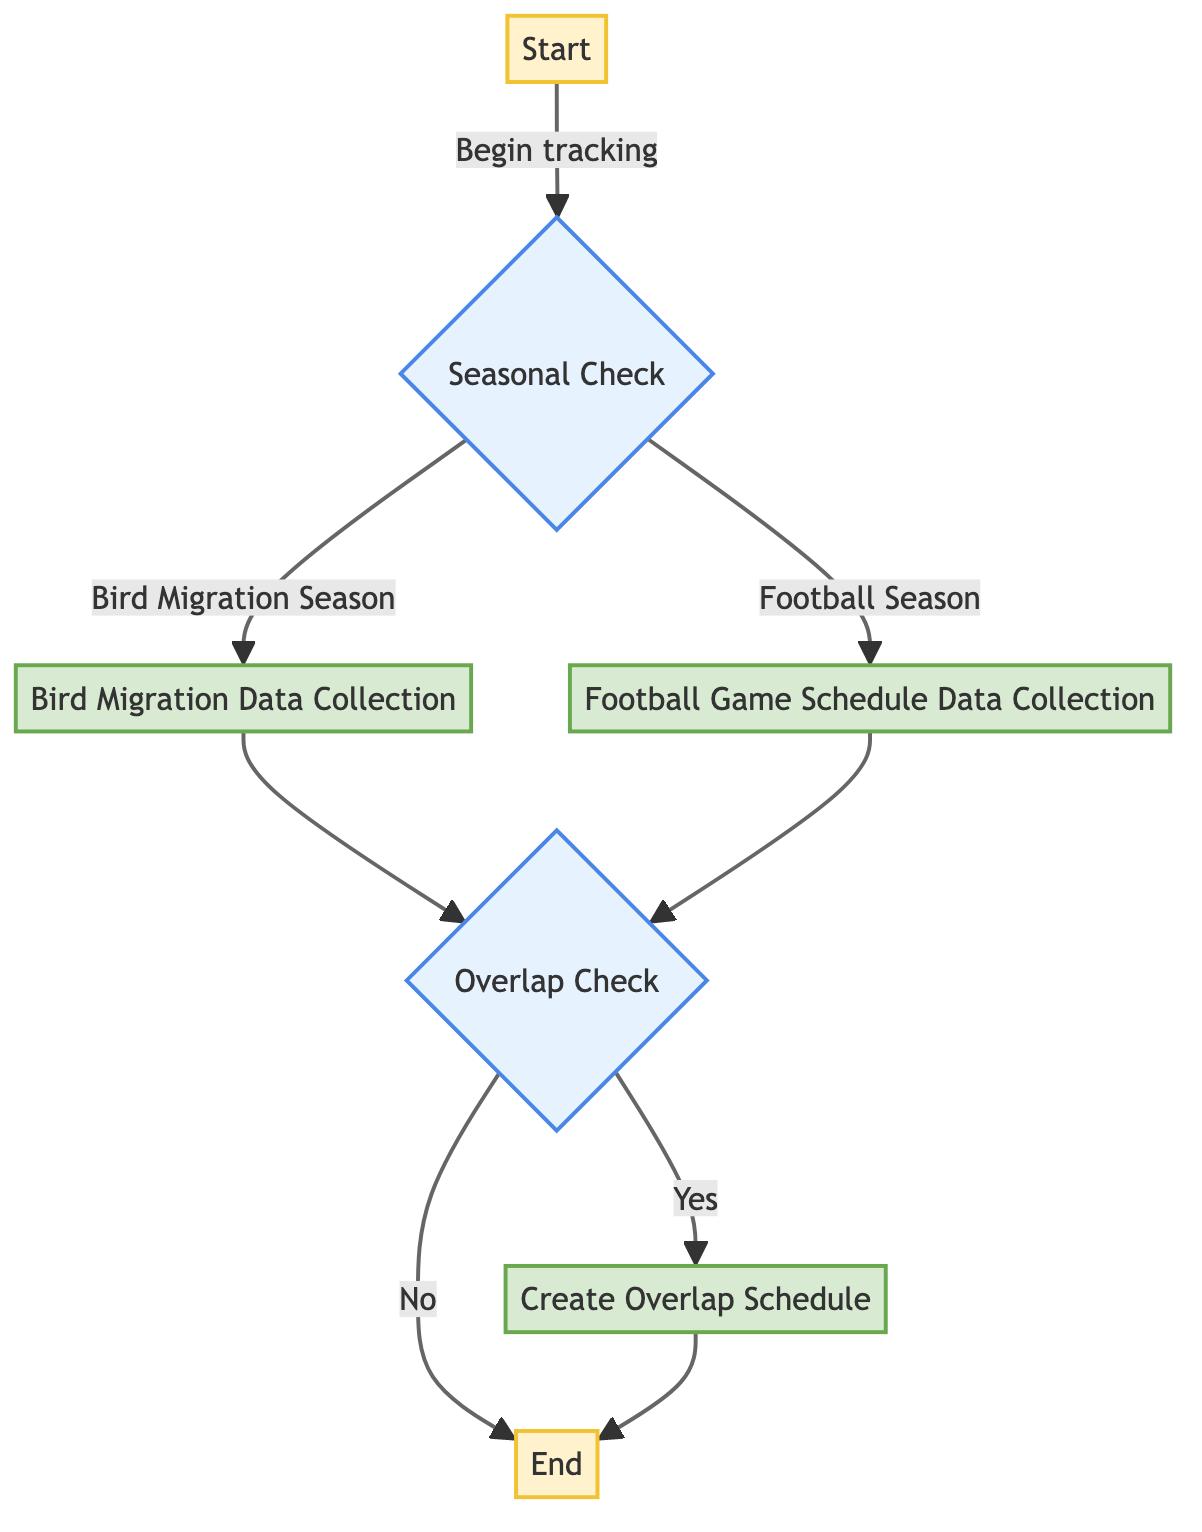What is the first step in the flowchart? The first step is labeled "Start," which indicates the initiation of tracking bird migrations and football seasons.
Answer: Start What are the two possible outcomes of the Seasonal Check? The Seasonal Check leads to two branches: "Bird Migration Season" and "Football Season."
Answer: Bird Migration Season, Football Season How many processes are there in the flowchart? The flowchart includes three processes: "Bird Migration Data Collection," "Football Game Schedule Data Collection," and "Create Overlap Schedule."
Answer: 3 What happens if there is an overlap of bird migrations and football games? If there is an overlap, the flowchart indicates that the next step is "Create Overlap Schedule."
Answer: Create Overlap Schedule What is the label of the second decision point? The second decision point is labeled "Overlap Check," which assesses whether bird migrations overlap with football games or not.
Answer: Overlap Check What action is taken if there is no overlap? If there is no overlap, the flowchart indicates that the process ends without creating a schedule.
Answer: End Which data source is mentioned for collecting bird migration data? The diagram mentions collecting bird migration data from sources like eBird, specifically for species like the American Robin and Red-winged Blackbird.
Answer: eBird What does the flowchart depict at the end of the process? At the end of the process, the flowchart states to "Share overlapping schedules with fellow nature enthusiasts."
Answer: Share overlapping schedules What is the purpose of the "Football Game Schedule Data Collection" step? The purpose of this step is to gather game schedules from leagues like the NFL and college football to understand game timing.
Answer: Collect game schedules How many branches are created from the Seasonal Check decision point? The Seasonal Check decision point creates two branches leading to either bird migration season or football season.
Answer: 2 